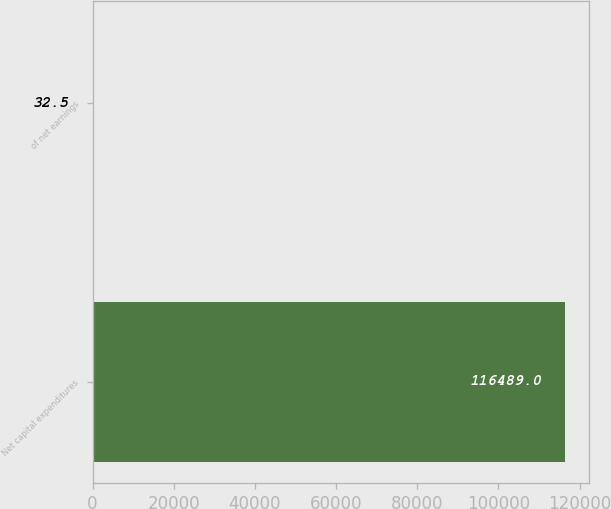Convert chart to OTSL. <chart><loc_0><loc_0><loc_500><loc_500><bar_chart><fcel>Net capital expenditures<fcel>of net earnings<nl><fcel>116489<fcel>32.5<nl></chart> 